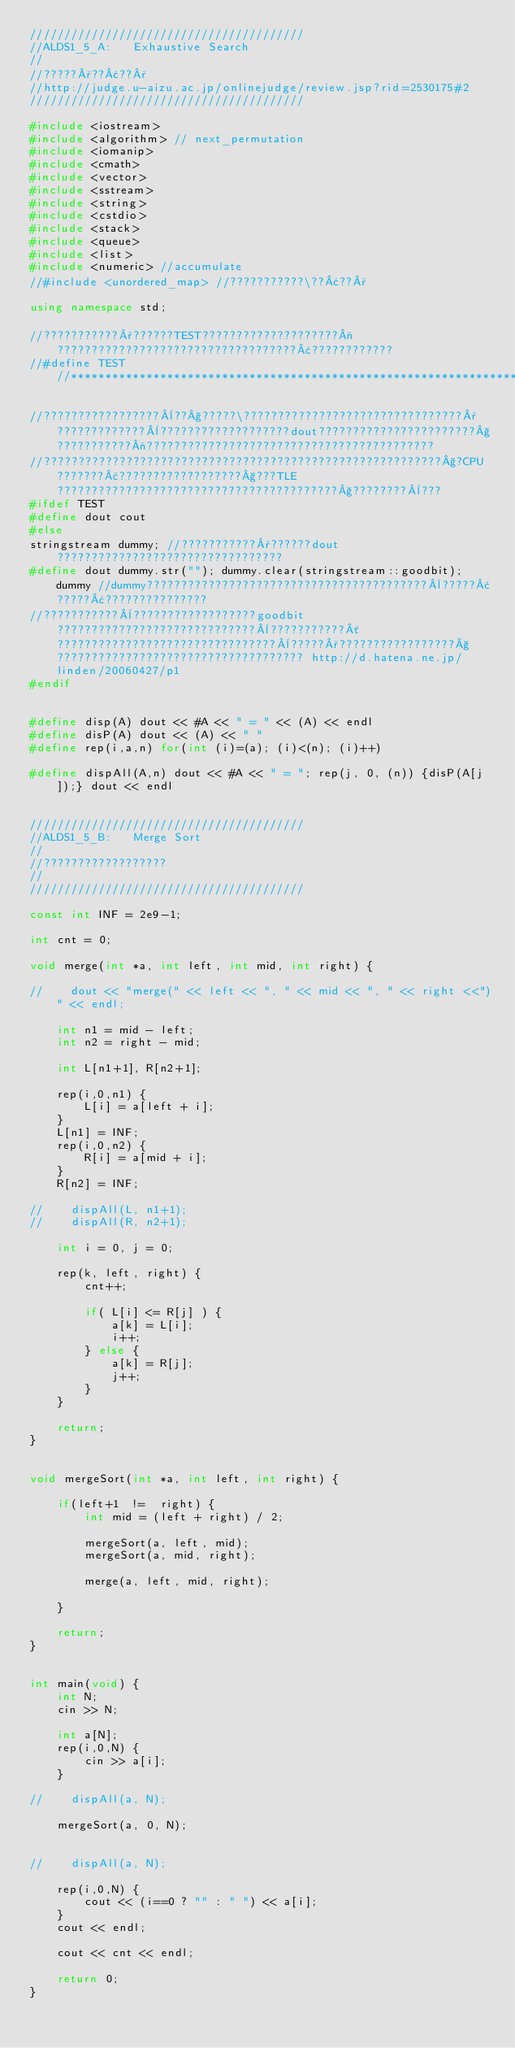<code> <loc_0><loc_0><loc_500><loc_500><_C++_>////////////////////////////////////////
//ALDS1_5_A:   Exhaustive Search
//
//?????°??¢??°
//http://judge.u-aizu.ac.jp/onlinejudge/review.jsp?rid=2530175#2
////////////////////////////////////////

#include <iostream>
#include <algorithm> // next_permutation
#include <iomanip>
#include <cmath>
#include <vector>
#include <sstream>
#include <string>
#include <cstdio>
#include <stack>
#include <queue>
#include <list>
#include <numeric> //accumulate
//#include <unordered_map> //???????????\??¢??°

using namespace std;

//???????????°??????TEST????????????????????¬???????????????????????????????????¢????????????
//#define TEST //*******************************************************************************************************************************************

//?????????????????¨??§?????\????????????????????????????????°?????????????¨???????????????????dout???????????????????????§???????????¬??????????????????????????????????????????
//??????????????????????????????????????????????????????????§?CPU???????£??????????????????§???TLE?????????????????????????????????????????§????????¨???
#ifdef TEST
#define dout cout
#else
stringstream dummy; //???????????°??????dout?????????????????????????????????
#define dout dummy.str(""); dummy.clear(stringstream::goodbit); dummy //dummy?????????????????????????????????????????¨?????¢?????¢???????????????
//???????????¨??????????????????goodbit?????????????????????????????¨???????????´????????????????????????????????¨?????°?????????????????§???????????????????????????????????? http://d.hatena.ne.jp/linden/20060427/p1
#endif


#define disp(A) dout << #A << " = " << (A) << endl
#define disP(A) dout << (A) << " "
#define rep(i,a,n) for(int (i)=(a); (i)<(n); (i)++)

#define dispAll(A,n) dout << #A << " = "; rep(j, 0, (n)) {disP(A[j]);} dout << endl


////////////////////////////////////////
//ALDS1_5_B:   Merge Sort
//
//??????????????????
//
////////////////////////////////////////

const int INF = 2e9-1;

int cnt = 0;

void merge(int *a, int left, int mid, int right) {
    
//    dout << "merge(" << left << ", " << mid << ", " << right <<")" << endl;
    
    int n1 = mid - left;
    int n2 = right - mid;
    
    int L[n1+1], R[n2+1];
    
    rep(i,0,n1) {
        L[i] = a[left + i];
    }
    L[n1] = INF;
    rep(i,0,n2) {
        R[i] = a[mid + i];
    }
    R[n2] = INF;
    
//    dispAll(L, n1+1);
//    dispAll(R, n2+1);
    
    int i = 0, j = 0;
    
    rep(k, left, right) {
        cnt++;
        
        if( L[i] <= R[j] ) {
            a[k] = L[i];
            i++;
        } else {
            a[k] = R[j];
            j++;
        }
    }

    return;
}


void mergeSort(int *a, int left, int right) {

    if(left+1  !=  right) {
        int mid = (left + right) / 2;
        
        mergeSort(a, left, mid);
        mergeSort(a, mid, right);
        
        merge(a, left, mid, right);
        
    }
    
    return;
}


int main(void) {
    int N;
    cin >> N;
    
    int a[N];
    rep(i,0,N) {
        cin >> a[i];
    }
    
//    dispAll(a, N);
    
    mergeSort(a, 0, N);
    
    
//    dispAll(a, N);
    
    rep(i,0,N) {
        cout << (i==0 ? "" : " ") << a[i];
    }
    cout << endl;
    
    cout << cnt << endl;
    
    return 0;
}</code> 